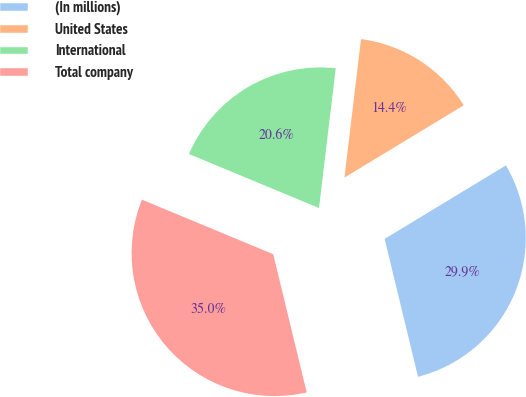<chart> <loc_0><loc_0><loc_500><loc_500><pie_chart><fcel>(In millions)<fcel>United States<fcel>International<fcel>Total company<nl><fcel>29.89%<fcel>14.43%<fcel>20.63%<fcel>35.05%<nl></chart> 